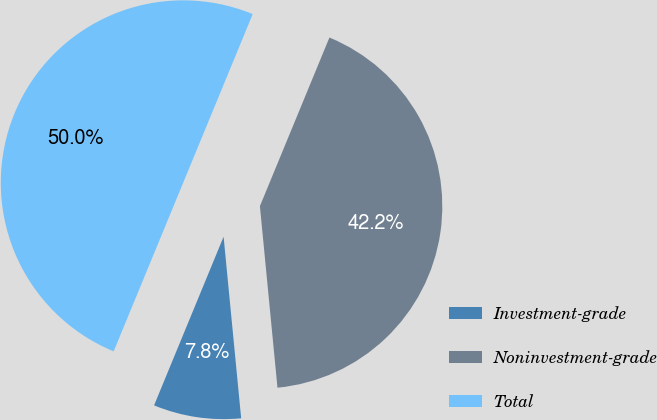<chart> <loc_0><loc_0><loc_500><loc_500><pie_chart><fcel>Investment-grade<fcel>Noninvestment-grade<fcel>Total<nl><fcel>7.76%<fcel>42.24%<fcel>50.0%<nl></chart> 